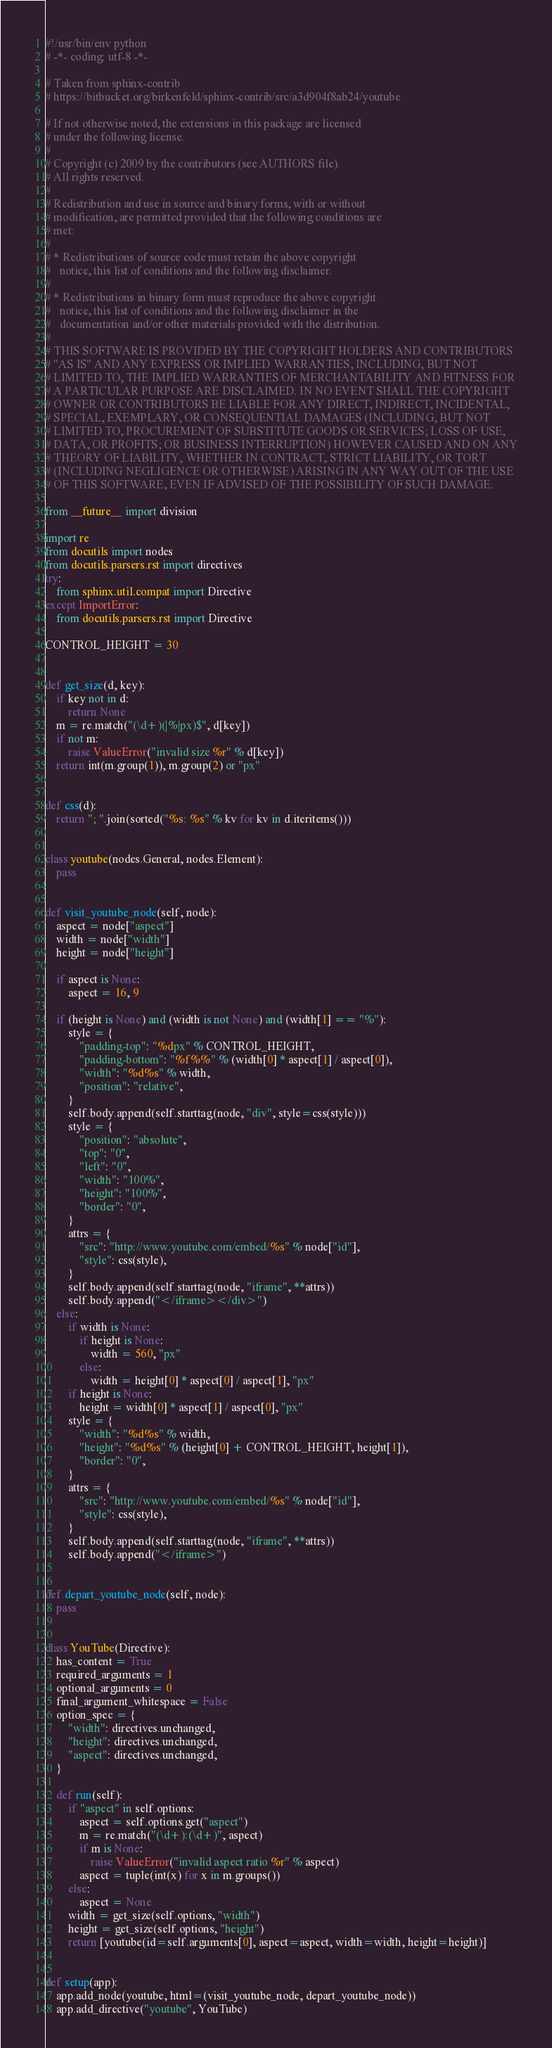Convert code to text. <code><loc_0><loc_0><loc_500><loc_500><_Python_>#!/usr/bin/env python
# -*- coding: utf-8 -*-

# Taken from sphinx-contrib
# https://bitbucket.org/birkenfeld/sphinx-contrib/src/a3d904f8ab24/youtube

# If not otherwise noted, the extensions in this package are licensed
# under the following license.
#
# Copyright (c) 2009 by the contributors (see AUTHORS file).
# All rights reserved.
#
# Redistribution and use in source and binary forms, with or without
# modification, are permitted provided that the following conditions are
# met:
#
# * Redistributions of source code must retain the above copyright
#   notice, this list of conditions and the following disclaimer.
#
# * Redistributions in binary form must reproduce the above copyright
#   notice, this list of conditions and the following disclaimer in the
#   documentation and/or other materials provided with the distribution.
#
# THIS SOFTWARE IS PROVIDED BY THE COPYRIGHT HOLDERS AND CONTRIBUTORS
# "AS IS" AND ANY EXPRESS OR IMPLIED WARRANTIES, INCLUDING, BUT NOT
# LIMITED TO, THE IMPLIED WARRANTIES OF MERCHANTABILITY AND FITNESS FOR
# A PARTICULAR PURPOSE ARE DISCLAIMED. IN NO EVENT SHALL THE COPYRIGHT
# OWNER OR CONTRIBUTORS BE LIABLE FOR ANY DIRECT, INDIRECT, INCIDENTAL,
# SPECIAL, EXEMPLARY, OR CONSEQUENTIAL DAMAGES (INCLUDING, BUT NOT
# LIMITED TO, PROCUREMENT OF SUBSTITUTE GOODS OR SERVICES; LOSS OF USE,
# DATA, OR PROFITS; OR BUSINESS INTERRUPTION) HOWEVER CAUSED AND ON ANY
# THEORY OF LIABILITY, WHETHER IN CONTRACT, STRICT LIABILITY, OR TORT
# (INCLUDING NEGLIGENCE OR OTHERWISE) ARISING IN ANY WAY OUT OF THE USE
# OF THIS SOFTWARE, EVEN IF ADVISED OF THE POSSIBILITY OF SUCH DAMAGE.

from __future__ import division

import re
from docutils import nodes
from docutils.parsers.rst import directives
try:
    from sphinx.util.compat import Directive
except ImportError:
    from docutils.parsers.rst import Directive

CONTROL_HEIGHT = 30


def get_size(d, key):
    if key not in d:
        return None
    m = re.match("(\d+)(|%|px)$", d[key])
    if not m:
        raise ValueError("invalid size %r" % d[key])
    return int(m.group(1)), m.group(2) or "px"


def css(d):
    return "; ".join(sorted("%s: %s" % kv for kv in d.iteritems()))


class youtube(nodes.General, nodes.Element):
    pass


def visit_youtube_node(self, node):
    aspect = node["aspect"]
    width = node["width"]
    height = node["height"]

    if aspect is None:
        aspect = 16, 9

    if (height is None) and (width is not None) and (width[1] == "%"):
        style = {
            "padding-top": "%dpx" % CONTROL_HEIGHT,
            "padding-bottom": "%f%%" % (width[0] * aspect[1] / aspect[0]),
            "width": "%d%s" % width,
            "position": "relative",
        }
        self.body.append(self.starttag(node, "div", style=css(style)))
        style = {
            "position": "absolute",
            "top": "0",
            "left": "0",
            "width": "100%",
            "height": "100%",
            "border": "0",
        }
        attrs = {
            "src": "http://www.youtube.com/embed/%s" % node["id"],
            "style": css(style),
        }
        self.body.append(self.starttag(node, "iframe", **attrs))
        self.body.append("</iframe></div>")
    else:
        if width is None:
            if height is None:
                width = 560, "px"
            else:
                width = height[0] * aspect[0] / aspect[1], "px"
        if height is None:
            height = width[0] * aspect[1] / aspect[0], "px"
        style = {
            "width": "%d%s" % width,
            "height": "%d%s" % (height[0] + CONTROL_HEIGHT, height[1]),
            "border": "0",
        }
        attrs = {
            "src": "http://www.youtube.com/embed/%s" % node["id"],
            "style": css(style),
        }
        self.body.append(self.starttag(node, "iframe", **attrs))
        self.body.append("</iframe>")


def depart_youtube_node(self, node):
    pass


class YouTube(Directive):
    has_content = True
    required_arguments = 1
    optional_arguments = 0
    final_argument_whitespace = False
    option_spec = {
        "width": directives.unchanged,
        "height": directives.unchanged,
        "aspect": directives.unchanged,
    }

    def run(self):
        if "aspect" in self.options:
            aspect = self.options.get("aspect")
            m = re.match("(\d+):(\d+)", aspect)
            if m is None:
                raise ValueError("invalid aspect ratio %r" % aspect)
            aspect = tuple(int(x) for x in m.groups())
        else:
            aspect = None
        width = get_size(self.options, "width")
        height = get_size(self.options, "height")
        return [youtube(id=self.arguments[0], aspect=aspect, width=width, height=height)]


def setup(app):
    app.add_node(youtube, html=(visit_youtube_node, depart_youtube_node))
    app.add_directive("youtube", YouTube)
</code> 